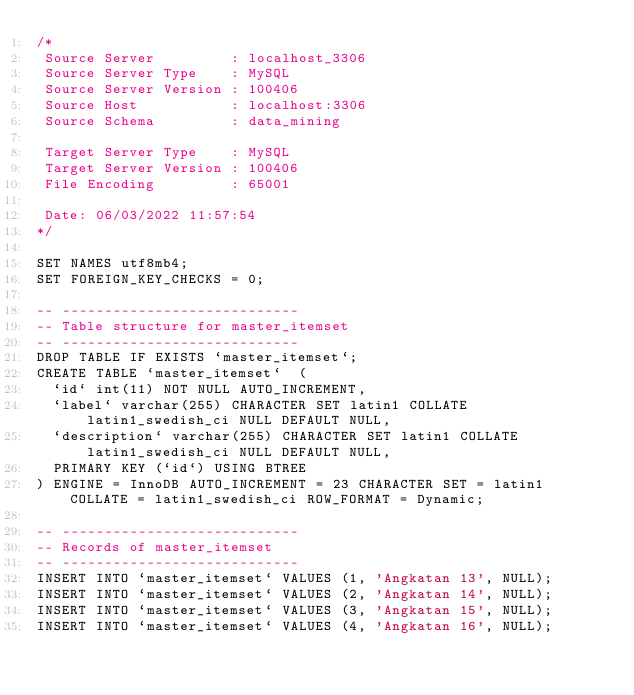<code> <loc_0><loc_0><loc_500><loc_500><_SQL_>/*
 Source Server         : localhost_3306
 Source Server Type    : MySQL
 Source Server Version : 100406
 Source Host           : localhost:3306
 Source Schema         : data_mining

 Target Server Type    : MySQL
 Target Server Version : 100406
 File Encoding         : 65001

 Date: 06/03/2022 11:57:54
*/

SET NAMES utf8mb4;
SET FOREIGN_KEY_CHECKS = 0;

-- ----------------------------
-- Table structure for master_itemset
-- ----------------------------
DROP TABLE IF EXISTS `master_itemset`;
CREATE TABLE `master_itemset`  (
  `id` int(11) NOT NULL AUTO_INCREMENT,
  `label` varchar(255) CHARACTER SET latin1 COLLATE latin1_swedish_ci NULL DEFAULT NULL,
  `description` varchar(255) CHARACTER SET latin1 COLLATE latin1_swedish_ci NULL DEFAULT NULL,
  PRIMARY KEY (`id`) USING BTREE
) ENGINE = InnoDB AUTO_INCREMENT = 23 CHARACTER SET = latin1 COLLATE = latin1_swedish_ci ROW_FORMAT = Dynamic;

-- ----------------------------
-- Records of master_itemset
-- ----------------------------
INSERT INTO `master_itemset` VALUES (1, 'Angkatan 13', NULL);
INSERT INTO `master_itemset` VALUES (2, 'Angkatan 14', NULL);
INSERT INTO `master_itemset` VALUES (3, 'Angkatan 15', NULL);
INSERT INTO `master_itemset` VALUES (4, 'Angkatan 16', NULL);</code> 